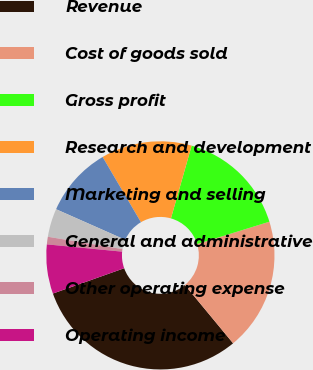Convert chart to OTSL. <chart><loc_0><loc_0><loc_500><loc_500><pie_chart><fcel>Revenue<fcel>Cost of goods sold<fcel>Gross profit<fcel>Research and development<fcel>Marketing and selling<fcel>General and administrative<fcel>Other operating expense<fcel>Operating income<nl><fcel>30.57%<fcel>18.77%<fcel>15.82%<fcel>12.87%<fcel>9.92%<fcel>4.02%<fcel>1.07%<fcel>6.97%<nl></chart> 